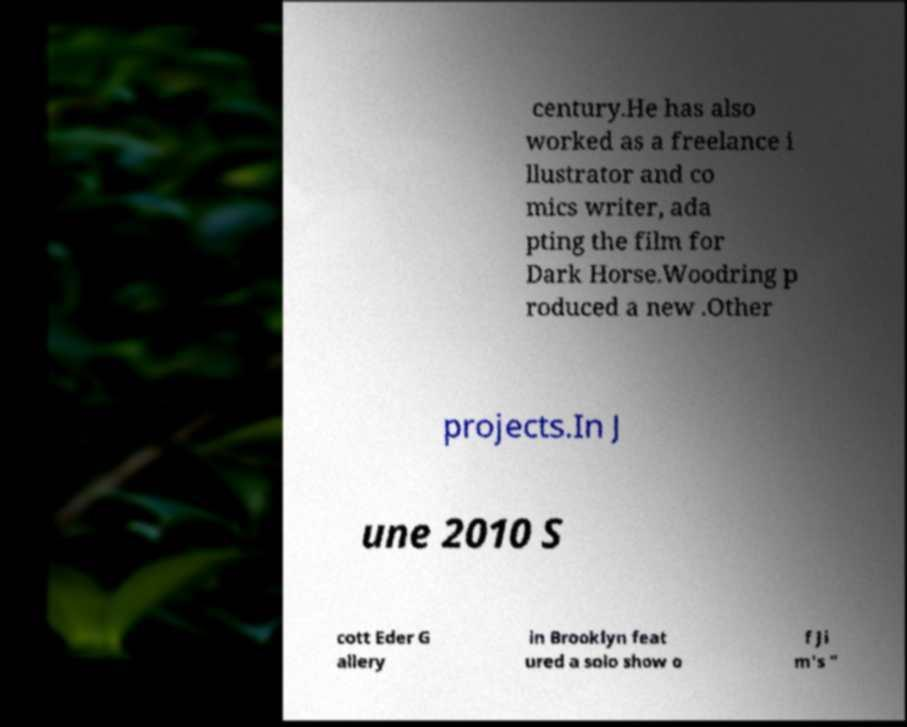Can you read and provide the text displayed in the image?This photo seems to have some interesting text. Can you extract and type it out for me? century.He has also worked as a freelance i llustrator and co mics writer, ada pting the film for Dark Horse.Woodring p roduced a new .Other projects.In J une 2010 S cott Eder G allery in Brooklyn feat ured a solo show o f Ji m's " 